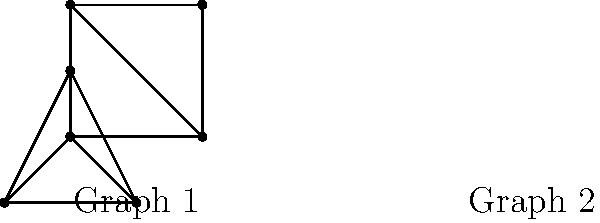Consider the two graphs shown above. Are these graphs isomorphic? If so, provide a bijective function $f$ that maps the vertices of Graph 1 to Graph 2, preserving adjacency. If not, explain why they are not isomorphic. To determine if the graphs are isomorphic, we need to check if there exists a bijective function that maps the vertices of one graph to the other while preserving adjacency. Let's approach this step-by-step:

1. First, we observe that both graphs have 4 vertices and 5 edges, which is a necessary (but not sufficient) condition for isomorphism.

2. In Graph 1, we have:
   - One vertex of degree 2 (top-left)
   - Two vertices of degree 3 (top-right and bottom-left)
   - One vertex of degree 4 (bottom-right)

3. In Graph 2, we have:
   - Three vertices of degree 3 (the outer triangle)
   - One vertex of degree 3 (the center)

4. The degree sequences match: [2, 3, 3, 4] for both graphs.

5. Let's try to construct a bijective function $f$:
   - The vertex of degree 2 in Graph 1 must map to one of the outer vertices in Graph 2.
   - The vertex of degree 4 in Graph 1 must map to the center vertex in Graph 2.
   - The two vertices of degree 3 in Graph 1 must map to the other two outer vertices in Graph 2.

6. We can define $f$ as follows (using clockwise labeling from top-left for Graph 1, and clockwise from top for Graph 2):
   $f(A) = B'$
   $f(B) = C'$
   $f(C) = A'$
   $f(D) = D'$ (center)

7. Checking adjacency preservation:
   - A is adjacent to B, C, D in Graph 1
     B' is adjacent to C', A', D' in Graph 2
   - B is adjacent to A, C, D in Graph 1
     C' is adjacent to B', A', D' in Graph 2
   - C is adjacent to A, B, D in Graph 1
     A' is adjacent to B', C', D' in Graph 2
   - D is adjacent to A, B, C in Graph 1
     D' is adjacent to A', B', C' in Graph 2

8. The function $f$ preserves adjacency for all vertices.

Therefore, the graphs are isomorphic, and we have found a bijective function $f$ that demonstrates this isomorphism.
Answer: Yes, the graphs are isomorphic. A bijective function $f$ that demonstrates this is: $f(A) = B'$, $f(B) = C'$, $f(C) = A'$, $f(D) = D'$ (center). 